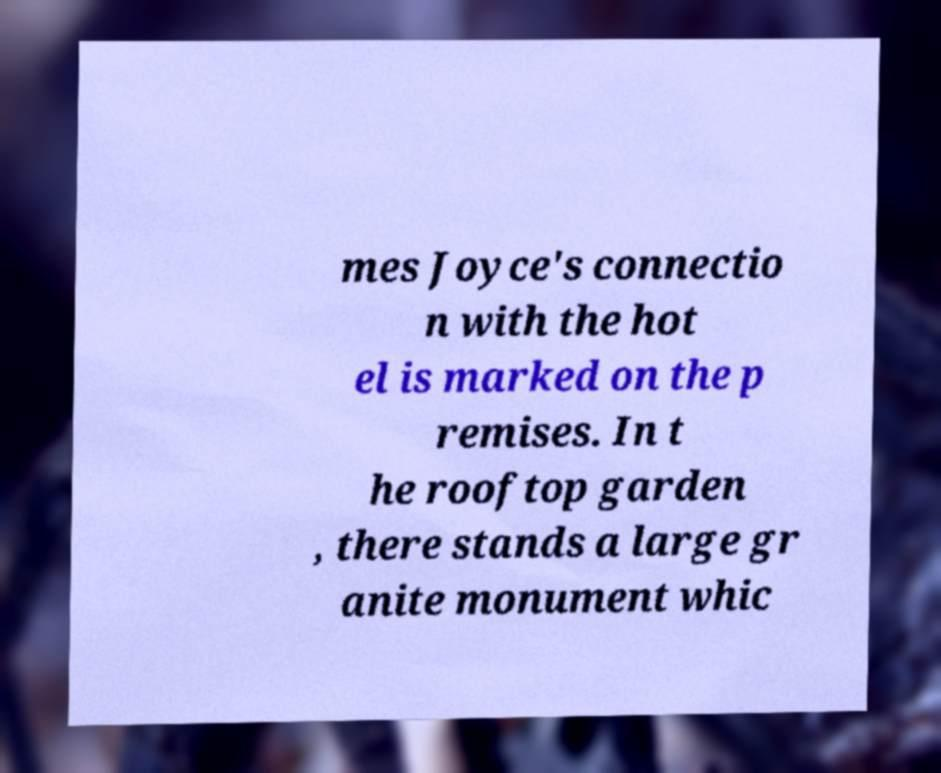Please identify and transcribe the text found in this image. mes Joyce's connectio n with the hot el is marked on the p remises. In t he rooftop garden , there stands a large gr anite monument whic 